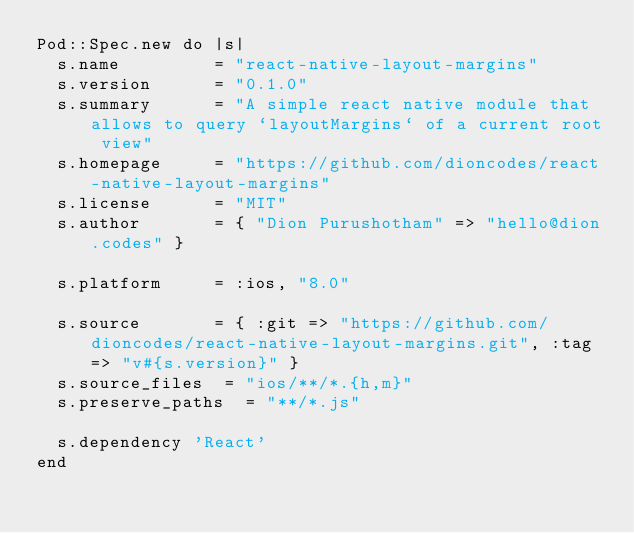<code> <loc_0><loc_0><loc_500><loc_500><_Ruby_>Pod::Spec.new do |s|
  s.name         = "react-native-layout-margins"
  s.version      = "0.1.0"
  s.summary      = "A simple react native module that allows to query `layoutMargins` of a current root view"
  s.homepage     = "https://github.com/dioncodes/react-native-layout-margins"
  s.license      = "MIT"
  s.author       = { "Dion Purushotham" => "hello@dion.codes" }

  s.platform     = :ios, "8.0"

  s.source       = { :git => "https://github.com/dioncodes/react-native-layout-margins.git", :tag => "v#{s.version}" }
  s.source_files  = "ios/**/*.{h,m}"
  s.preserve_paths  = "**/*.js"

  s.dependency 'React'
end
</code> 